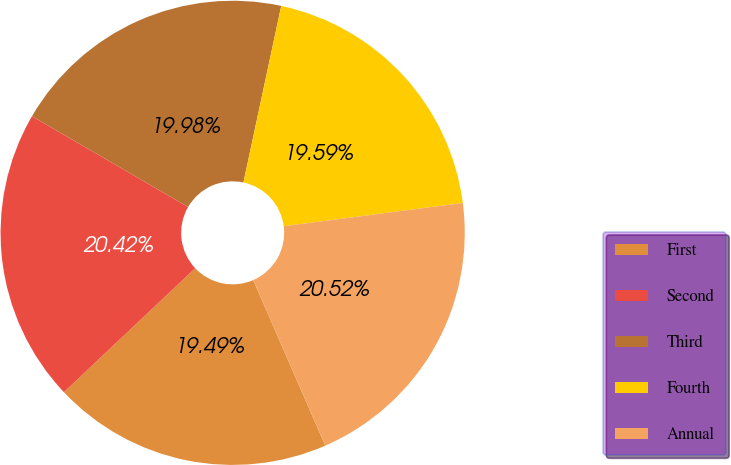<chart> <loc_0><loc_0><loc_500><loc_500><pie_chart><fcel>First<fcel>Second<fcel>Third<fcel>Fourth<fcel>Annual<nl><fcel>19.49%<fcel>20.42%<fcel>19.98%<fcel>19.59%<fcel>20.52%<nl></chart> 